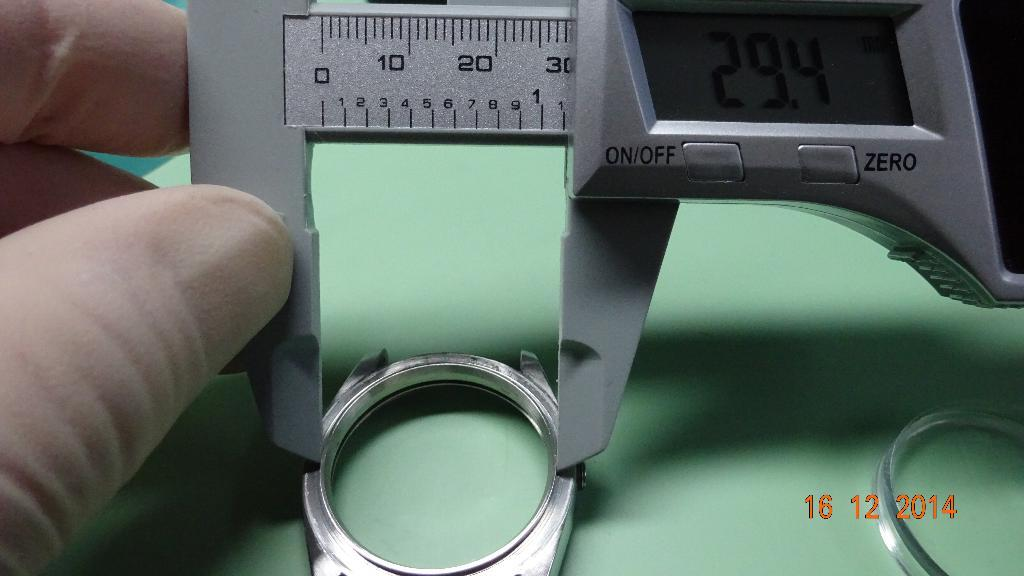<image>
Write a terse but informative summary of the picture. A person is holding a measuring device that has an on/off switch. 